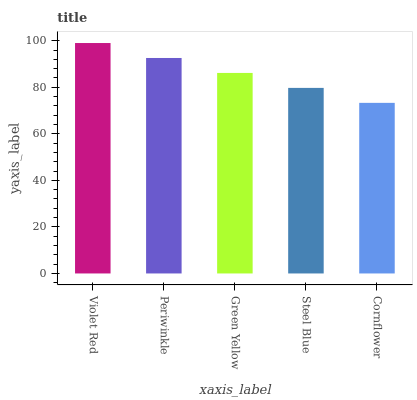Is Cornflower the minimum?
Answer yes or no. Yes. Is Violet Red the maximum?
Answer yes or no. Yes. Is Periwinkle the minimum?
Answer yes or no. No. Is Periwinkle the maximum?
Answer yes or no. No. Is Violet Red greater than Periwinkle?
Answer yes or no. Yes. Is Periwinkle less than Violet Red?
Answer yes or no. Yes. Is Periwinkle greater than Violet Red?
Answer yes or no. No. Is Violet Red less than Periwinkle?
Answer yes or no. No. Is Green Yellow the high median?
Answer yes or no. Yes. Is Green Yellow the low median?
Answer yes or no. Yes. Is Periwinkle the high median?
Answer yes or no. No. Is Steel Blue the low median?
Answer yes or no. No. 